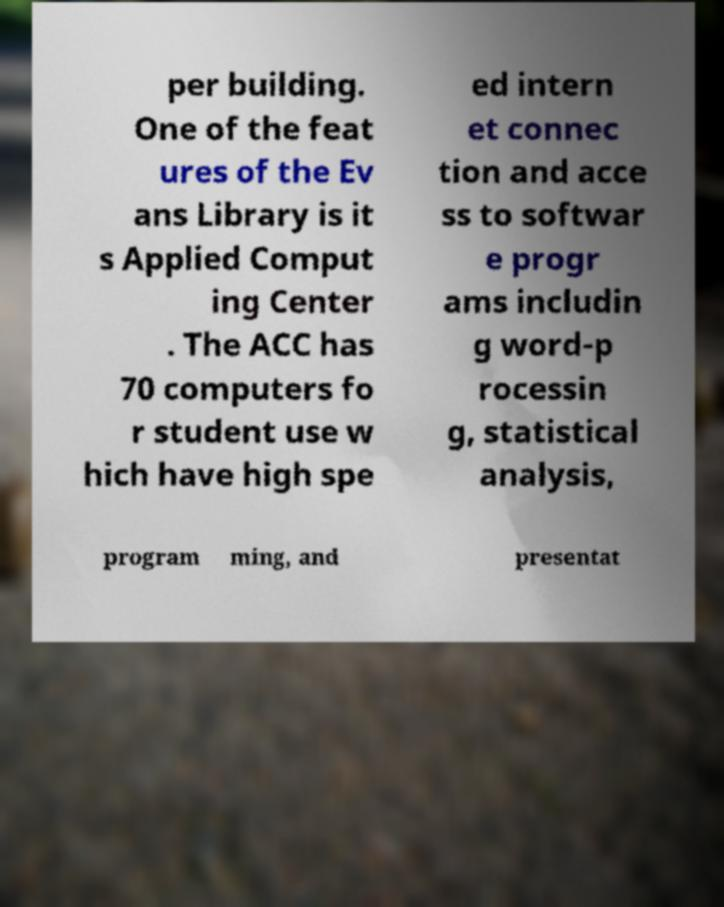Can you accurately transcribe the text from the provided image for me? per building. One of the feat ures of the Ev ans Library is it s Applied Comput ing Center . The ACC has 70 computers fo r student use w hich have high spe ed intern et connec tion and acce ss to softwar e progr ams includin g word-p rocessin g, statistical analysis, program ming, and presentat 